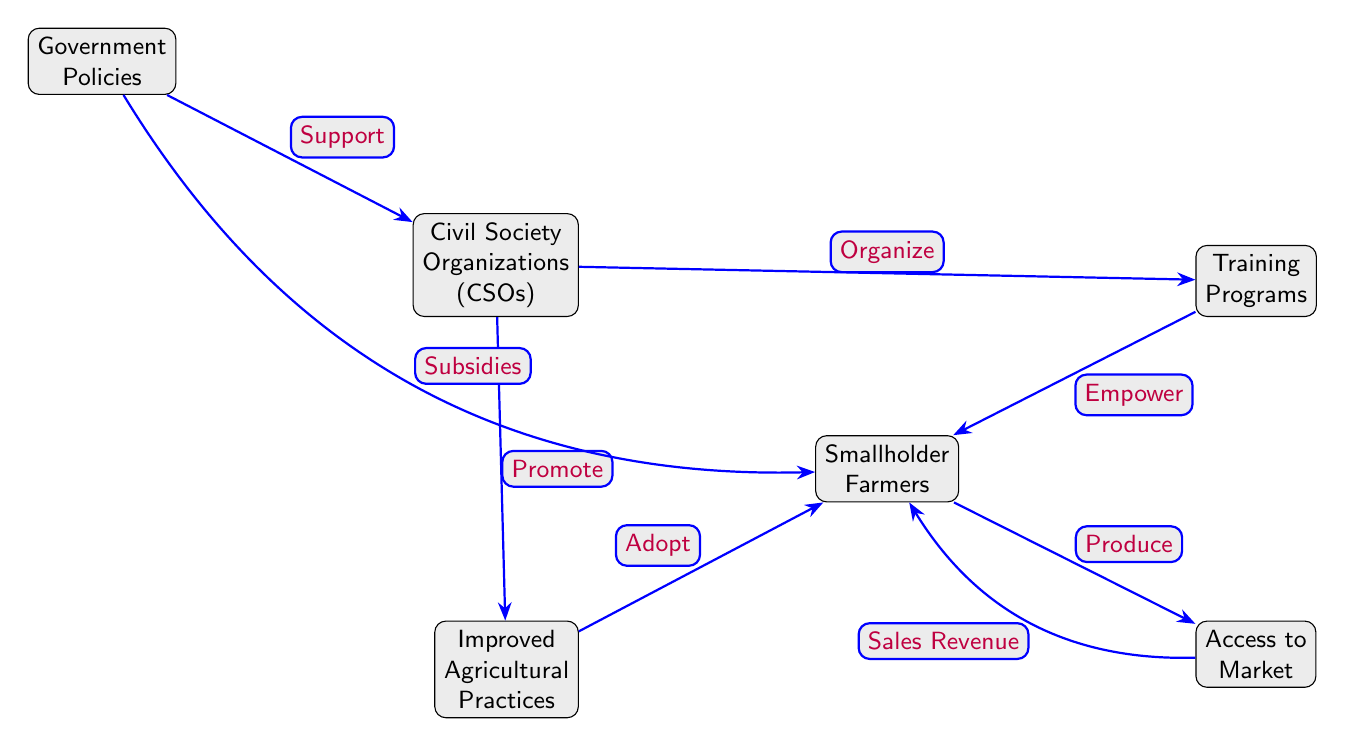What are the nodes in the diagram? The nodes in the diagram include Civil Society Organizations (CSOs), Smallholder Farmers, Training Programs, Access to Market, Improved Agricultural Practices, and Government Policies.
Answer: Civil Society Organizations, Smallholder Farmers, Training Programs, Access to Market, Improved Agricultural Practices, Government Policies How many edges are in the diagram? The diagram has six edges connecting the nodes. Each connection indicates a relationship or flow between nodes.
Answer: 6 What does the CSO node do to the Training Programs? The CSO node organizes the Training Programs. This is indicated by the directional arrow from CSO to Training Programs labeled "Organize."
Answer: Organize What does the Government Policies node provide to the Smallholder Farmers? Government Policies provide subsidies to Smallholder Farmers, as indicated by the arrow from Government Policies to Smallholder Farmers labeled "Subsidies."
Answer: Subsidies What action do Smallholder Farmers take after receiving training? After receiving training, Smallholder Farmers are empowered, which is indicated by the arrow from Training Programs to Smallholder Farmers labeled "Empower."
Answer: Empower How do Improved Agricultural Practices affect Smallholder Farmers? Improved Agricultural Practices lead Smallholder Farmers to adopt new methods, as indicated by the arrow from Improved Agricultural Practices to Smallholder Farmers labeled "Adopt."
Answer: Adopt What is the relationship between Access to Market and Smallholder Farmers? Smallholder Farmers produce based on Access to Market, and the sales revenue flows back to them, as shown by the arrows connecting these two nodes labeled "Produce" and "Sales Revenue."
Answer: Produce What role do Civil Society Organizations have regarding Improved Agricultural Practices? Civil Society Organizations promote Improved Agricultural Practices, which is indicated by the arrow from CSOs to Improved Agricultural Practices labeled "Promote."
Answer: Promote What node is above the Smallholder Farmers node? The node above Smallholder Farmers is the Training Programs node. This indicates that Training Programs are a source of empowerment for Smallholder Farmers.
Answer: Training Programs 